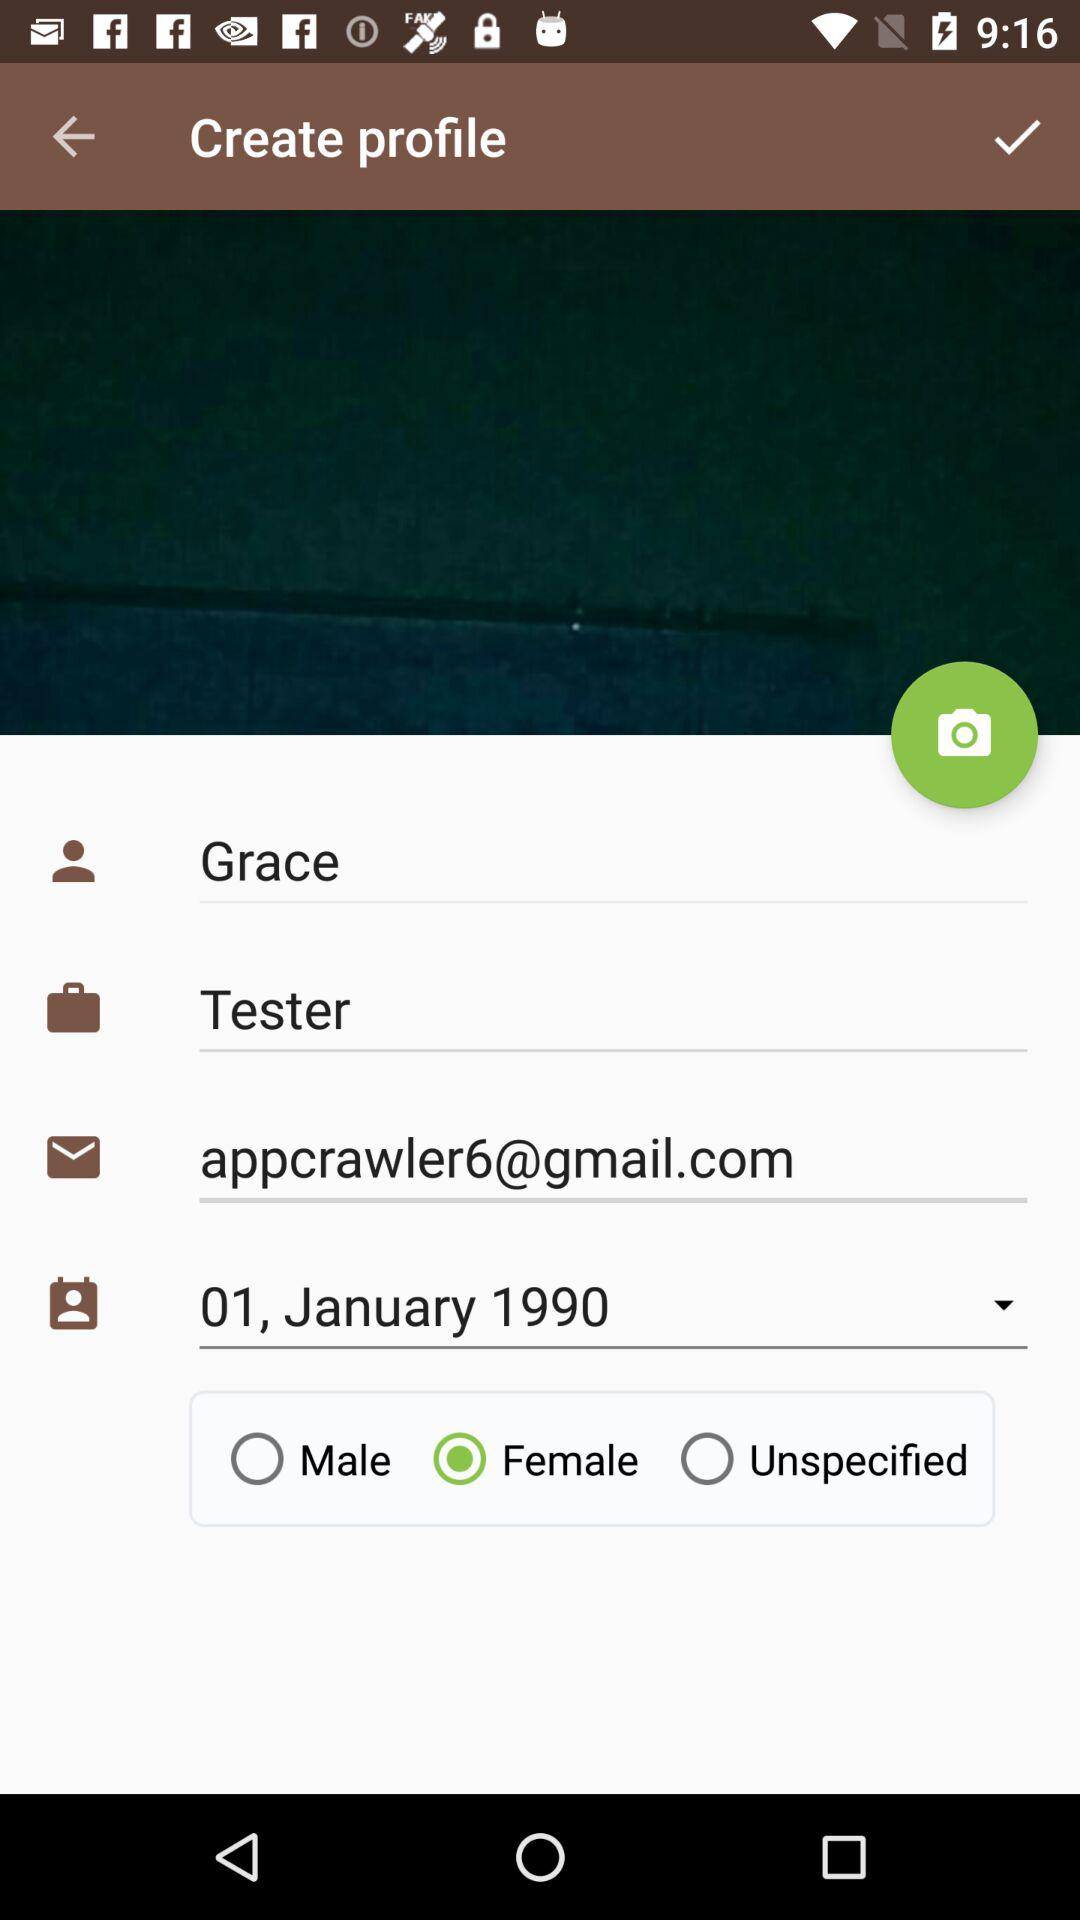What is the selected date? The selected date is January 1, 1990. 